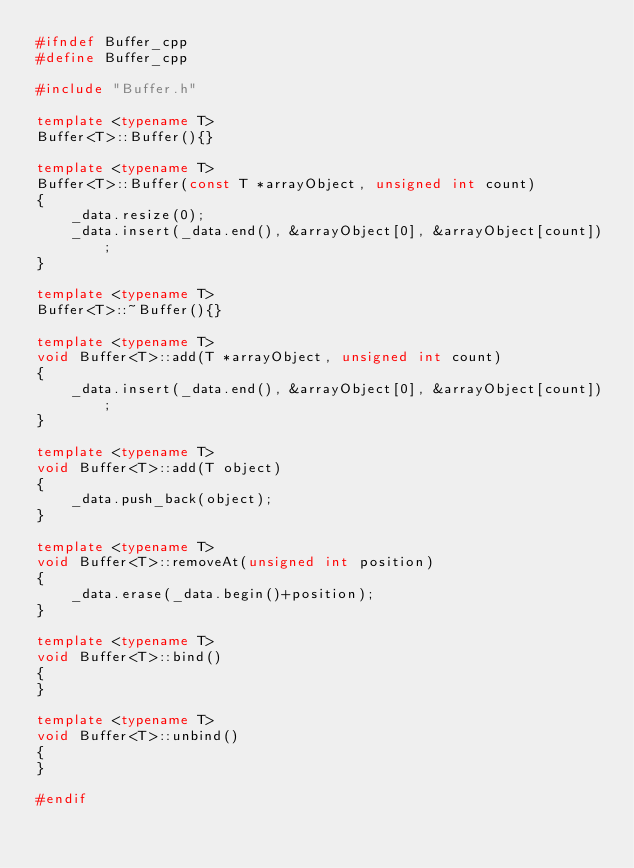<code> <loc_0><loc_0><loc_500><loc_500><_C++_>#ifndef Buffer_cpp
#define Buffer_cpp

#include "Buffer.h"

template <typename T>
Buffer<T>::Buffer(){}

template <typename T>
Buffer<T>::Buffer(const T *arrayObject, unsigned int count)
{
    _data.resize(0);
    _data.insert(_data.end(), &arrayObject[0], &arrayObject[count]);
}

template <typename T>
Buffer<T>::~Buffer(){}

template <typename T>
void Buffer<T>::add(T *arrayObject, unsigned int count)
{
    _data.insert(_data.end(), &arrayObject[0], &arrayObject[count]);
}

template <typename T>
void Buffer<T>::add(T object)
{
    _data.push_back(object);
}

template <typename T>
void Buffer<T>::removeAt(unsigned int position)
{
    _data.erase(_data.begin()+position);
}

template <typename T>
void Buffer<T>::bind()
{
}

template <typename T>
void Buffer<T>::unbind()
{
}

#endif</code> 